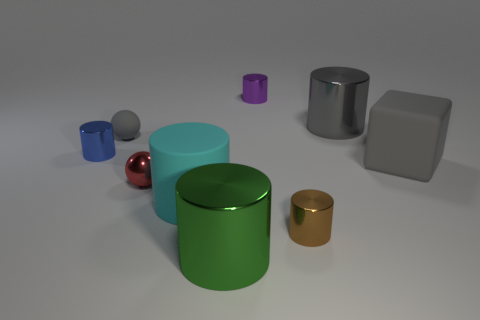Subtract all shiny cylinders. How many cylinders are left? 1 Subtract all gray spheres. How many spheres are left? 1 Subtract 1 blocks. How many blocks are left? 0 Subtract all tiny yellow rubber spheres. Subtract all tiny matte spheres. How many objects are left? 8 Add 2 small purple cylinders. How many small purple cylinders are left? 3 Add 3 matte objects. How many matte objects exist? 6 Subtract 1 gray blocks. How many objects are left? 8 Subtract all cylinders. How many objects are left? 3 Subtract all purple cylinders. Subtract all purple cubes. How many cylinders are left? 5 